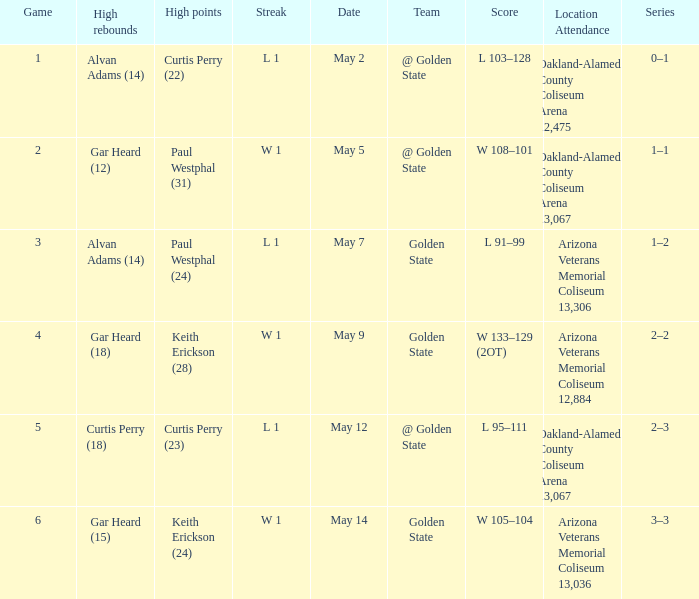How many games had they won or lost in a row on May 9? W 1. 